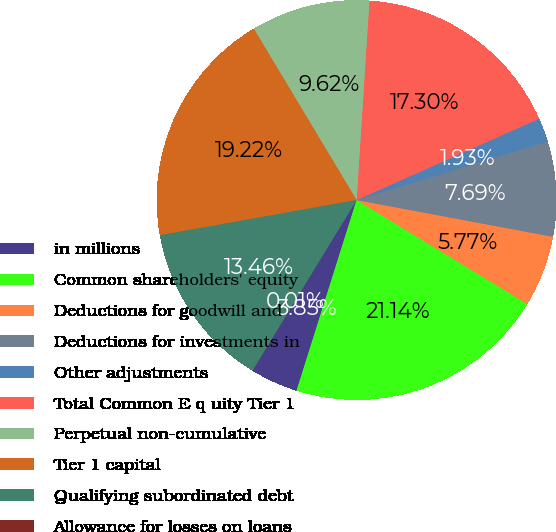Convert chart. <chart><loc_0><loc_0><loc_500><loc_500><pie_chart><fcel>in millions<fcel>Common shareholders' equity<fcel>Deductions for goodwill and<fcel>Deductions for investments in<fcel>Other adjustments<fcel>Total Common E q uity Tier 1<fcel>Perpetual non-cumulative<fcel>Tier 1 capital<fcel>Qualifying subordinated debt<fcel>Allowance for losses on loans<nl><fcel>3.85%<fcel>21.14%<fcel>5.77%<fcel>7.69%<fcel>1.93%<fcel>17.3%<fcel>9.62%<fcel>19.22%<fcel>13.46%<fcel>0.01%<nl></chart> 